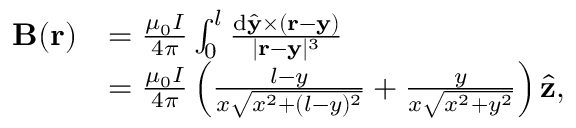Convert formula to latex. <formula><loc_0><loc_0><loc_500><loc_500>\begin{array} { r l } { B ( r ) } & { = \frac { \mu _ { 0 } I } { 4 \pi } \int _ { 0 } ^ { l } \frac { d \hat { y } \times ( r - y ) } { | r - y | ^ { 3 } } } \\ & { = \frac { \mu _ { 0 } I } { 4 \pi } \left ( \frac { l - y } { x \sqrt { x ^ { 2 } + ( l - y ) ^ { 2 } } } + \frac { y } { x \sqrt { x ^ { 2 } + y ^ { 2 } } } \right ) \hat { z } , } \end{array}</formula> 